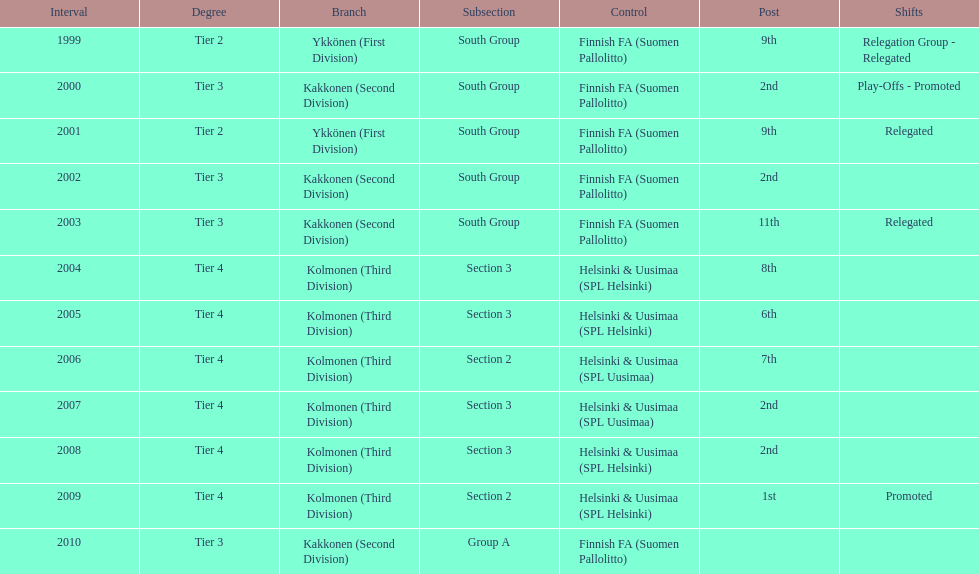How many consecutive times did they play in tier 4? 6. 